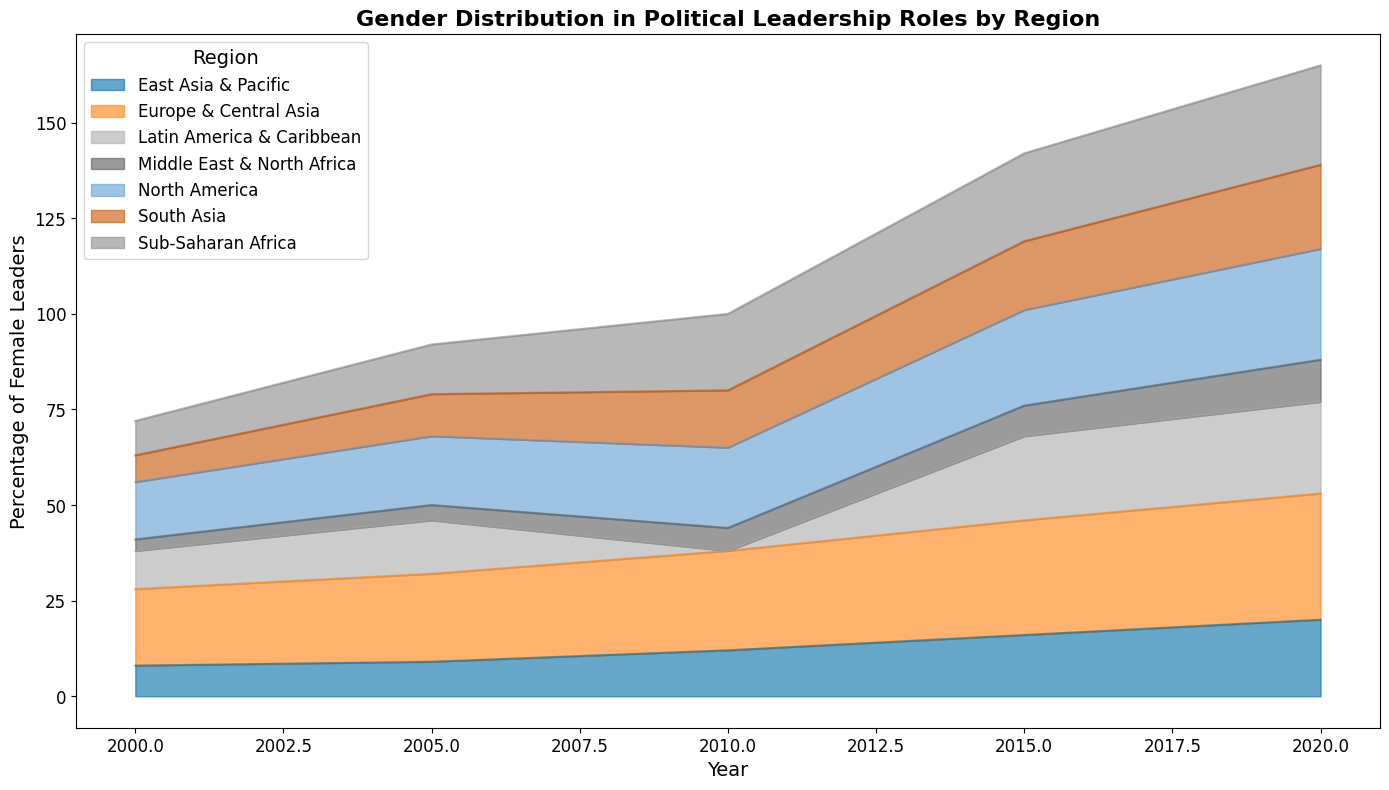What region had the highest percentage of female leaders in 2020? From the area chart, the highest section in 2020 is colored for Europe & Central Asia.
Answer: Europe & Central Asia What is the percentage increase of female leaders in Sub-Saharan Africa from 2000 to 2020? Sub-Saharan Africa had 9% in 2000 and 26% in 2020. The increase is 26% - 9% = 17%.
Answer: 17% Compare the percentage of female leaders in South Asia and East Asia & Pacific in 2010. Which region had more? In 2010, South Asia had 15%, while East Asia & Pacific had 12%. Therefore, South Asia had more.
Answer: South Asia What regions had a higher percentage of female leaders than North America in 2015? North America had 25% in 2015. Both Europe & Central Asia, which had 30%, was higher than North America. No other region exceeded 25%.
Answer: Europe & Central Asia Approximately, what is the average percentage of female leaders in Latin America & Caribbean across the years provided? The percentages are 10, 14, 22, 24. Calculating the average: (10 + 14 + 22 + 24)/4 = 17.5%.
Answer: 17.5% In which year did Middle East & North Africa present its highest percentage of female leaders, and what was the value? From the area chart, Middle East & North Africa reached its highest in 2020 with 11%.
Answer: 2020, 11% How did the percentage of female leaders in East Asia & Pacific change from 2000 to 2020? In 2000, East Asia & Pacific had 8%, rising to 20% by 2020. The change is 20% - 8% = 12%.
Answer: 12% Which region saw the smallest percentage increase in female leaders from 2000 to 2020? Middle East & North Africa increased from 3% in 2000 to 11% in 2020, which is an increase of 8%. This is the smallest among the regions.
Answer: Middle East & North Africa Which regions had a higher percentage of female leaders than the average percentage shown in Sub-Saharan Africa in 2015? The average in Sub-Saharan Africa in 2015 is 23%. Europe & Central Asia (30%), North America (25%), and Latin America & Caribbean (22%) were more than 23%.
Answer: Europe & Central Asia, North America What is the sum of female leaders' percentage increase in all developing regions combined from 2000 to 2020? Sum for Sub-Saharan Africa: 17%, South Asia: 15%, East Asia & Pacific: 12%, Latin America & Caribbean: 14%, Middle East & North Africa: 8%. Sum: 17 + 15 + 12 + 14 + 8 = 66%.
Answer: 66% 